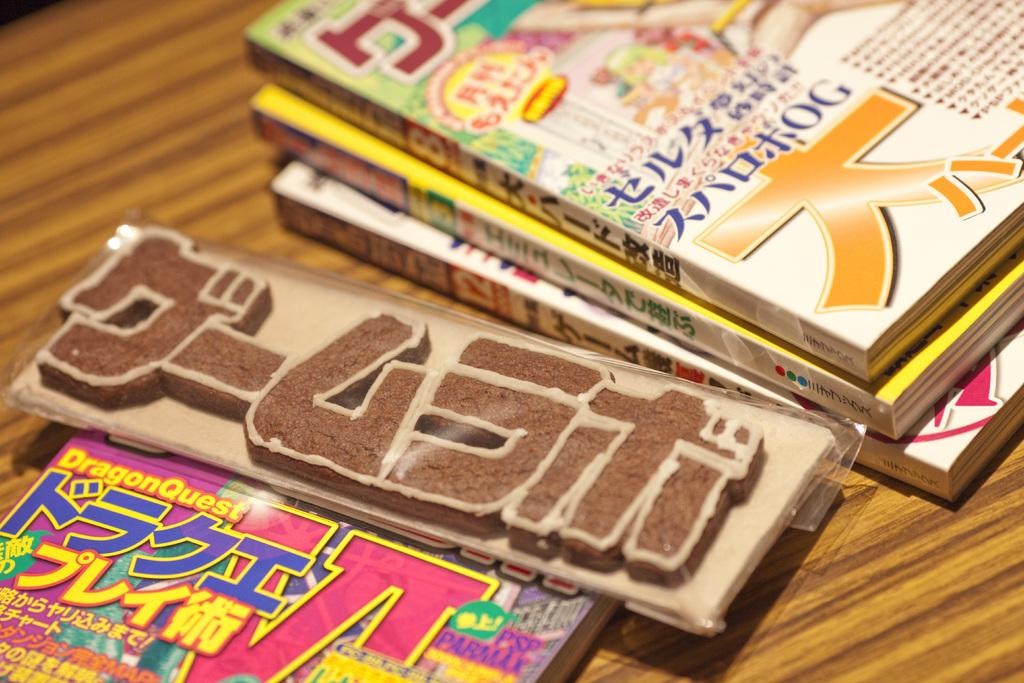<image>
Describe the image concisely. Stacks of magazines are on a table and the closest one has DragonQuest at the top. 